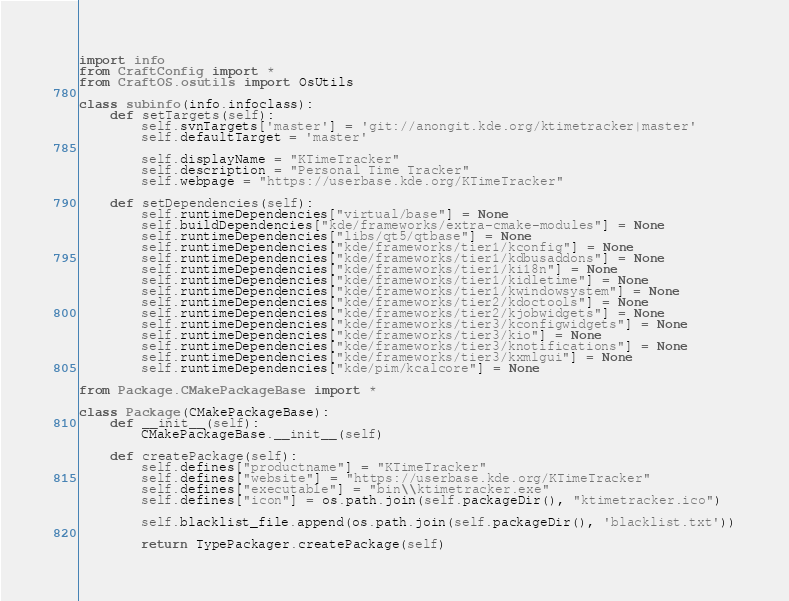<code> <loc_0><loc_0><loc_500><loc_500><_Python_>import info
from CraftConfig import *
from CraftOS.osutils import OsUtils

class subinfo(info.infoclass):
    def setTargets(self):
        self.svnTargets['master'] = 'git://anongit.kde.org/ktimetracker|master'
        self.defaultTarget = 'master'

        self.displayName = "KTimeTracker"
        self.description = "Personal Time Tracker"
        self.webpage = "https://userbase.kde.org/KTimeTracker"

    def setDependencies(self):
        self.runtimeDependencies["virtual/base"] = None
        self.buildDependencies["kde/frameworks/extra-cmake-modules"] = None
        self.runtimeDependencies["libs/qt5/qtbase"] = None
        self.runtimeDependencies["kde/frameworks/tier1/kconfig"] = None
        self.runtimeDependencies["kde/frameworks/tier1/kdbusaddons"] = None
        self.runtimeDependencies["kde/frameworks/tier1/ki18n"] = None
        self.runtimeDependencies["kde/frameworks/tier1/kidletime"] = None
        self.runtimeDependencies["kde/frameworks/tier1/kwindowsystem"] = None
        self.runtimeDependencies["kde/frameworks/tier2/kdoctools"] = None
        self.runtimeDependencies["kde/frameworks/tier2/kjobwidgets"] = None
        self.runtimeDependencies["kde/frameworks/tier3/kconfigwidgets"] = None
        self.runtimeDependencies["kde/frameworks/tier3/kio"] = None
        self.runtimeDependencies["kde/frameworks/tier3/knotifications"] = None
        self.runtimeDependencies["kde/frameworks/tier3/kxmlgui"] = None
        self.runtimeDependencies["kde/pim/kcalcore"] = None

from Package.CMakePackageBase import *

class Package(CMakePackageBase):
    def __init__(self):
        CMakePackageBase.__init__(self)

    def createPackage(self):
        self.defines["productname"] = "KTimeTracker"
        self.defines["website"] = "https://userbase.kde.org/KTimeTracker"
        self.defines["executable"] = "bin\\ktimetracker.exe"
        self.defines["icon"] = os.path.join(self.packageDir(), "ktimetracker.ico")

        self.blacklist_file.append(os.path.join(self.packageDir(), 'blacklist.txt'))

        return TypePackager.createPackage(self)
</code> 